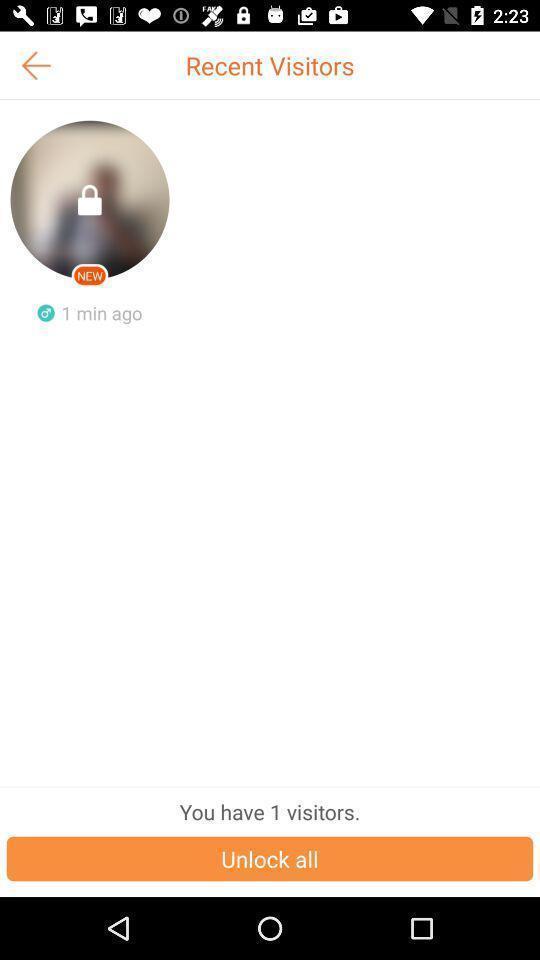Explain what's happening in this screen capture. Screen showing recent visitors. 